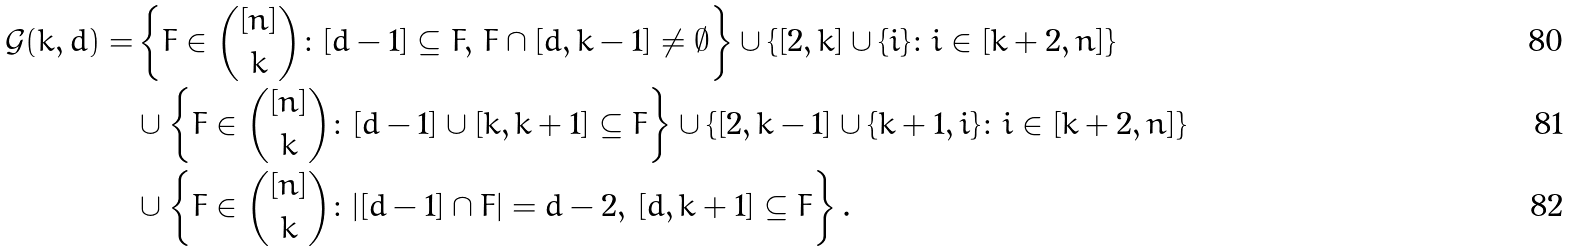Convert formula to latex. <formula><loc_0><loc_0><loc_500><loc_500>\mathcal { G } ( k , d ) = & \left \{ F \in \binom { [ n ] } { k } \colon [ d - 1 ] \subseteq F , \, F \cap [ d , k - 1 ] \neq \emptyset \right \} \cup \{ [ 2 , k ] \cup \{ i \} \colon i \in [ k + 2 , n ] \} \\ & \cup \left \{ F \in \binom { [ n ] } { k } \colon [ d - 1 ] \cup [ k , k + 1 ] \subseteq F \right \} \cup \{ [ 2 , k - 1 ] \cup \{ k + 1 , i \} \colon i \in [ k + 2 , n ] \} \\ & \cup \left \{ F \in \binom { [ n ] } { k } \colon | [ d - 1 ] \cap F | = d - 2 , \, [ d , k + 1 ] \subseteq F \right \} .</formula> 